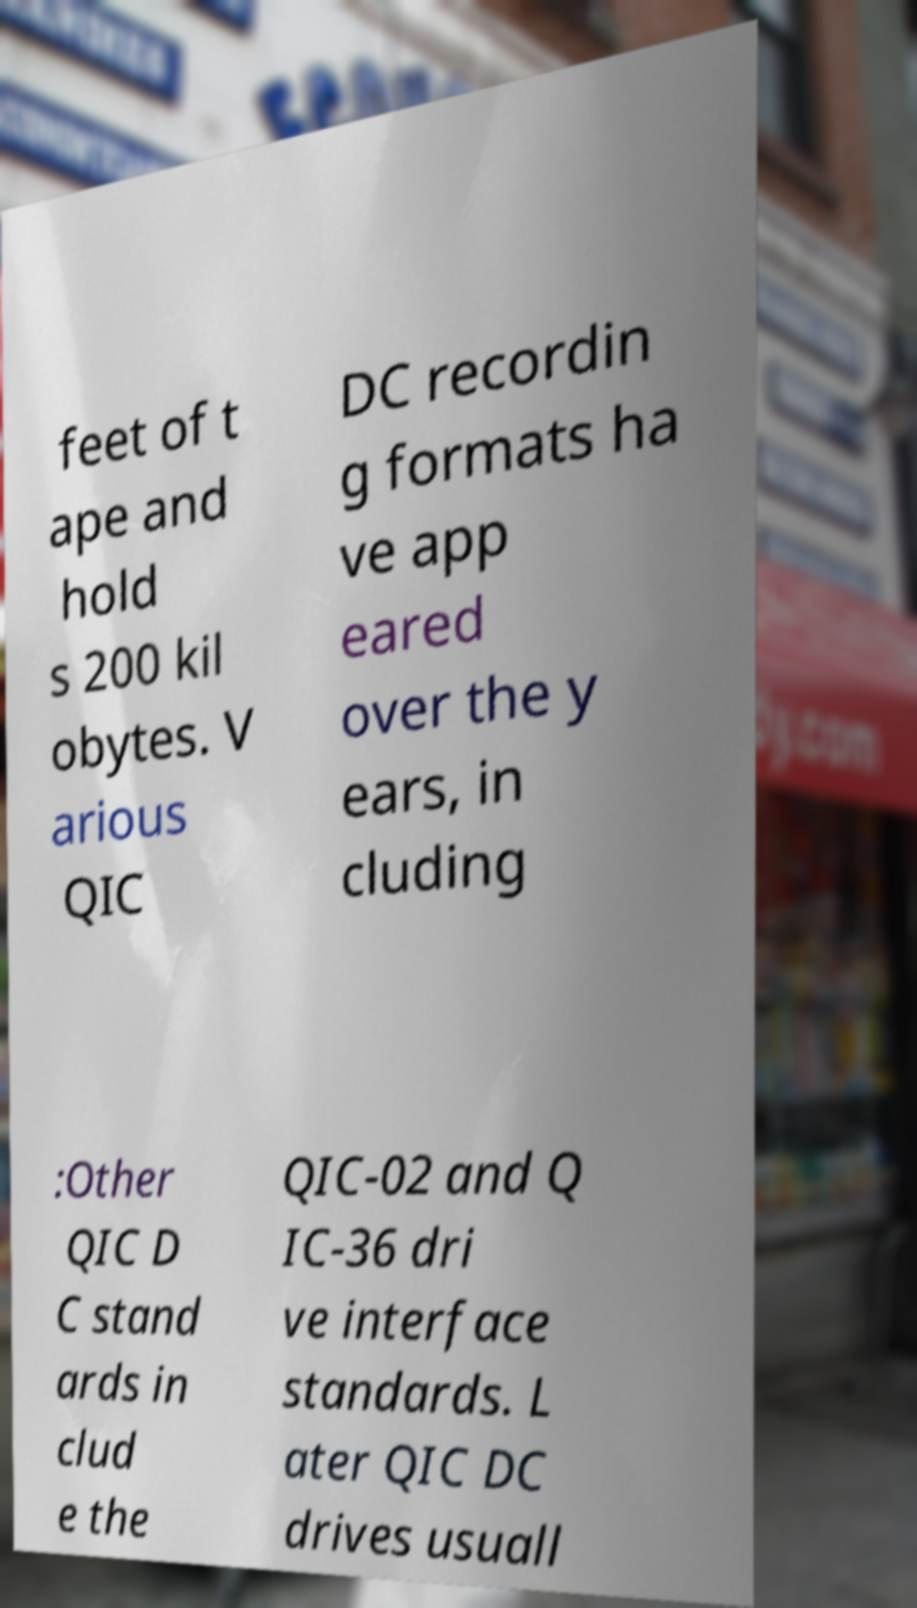Please read and relay the text visible in this image. What does it say? feet of t ape and hold s 200 kil obytes. V arious QIC DC recordin g formats ha ve app eared over the y ears, in cluding :Other QIC D C stand ards in clud e the QIC-02 and Q IC-36 dri ve interface standards. L ater QIC DC drives usuall 